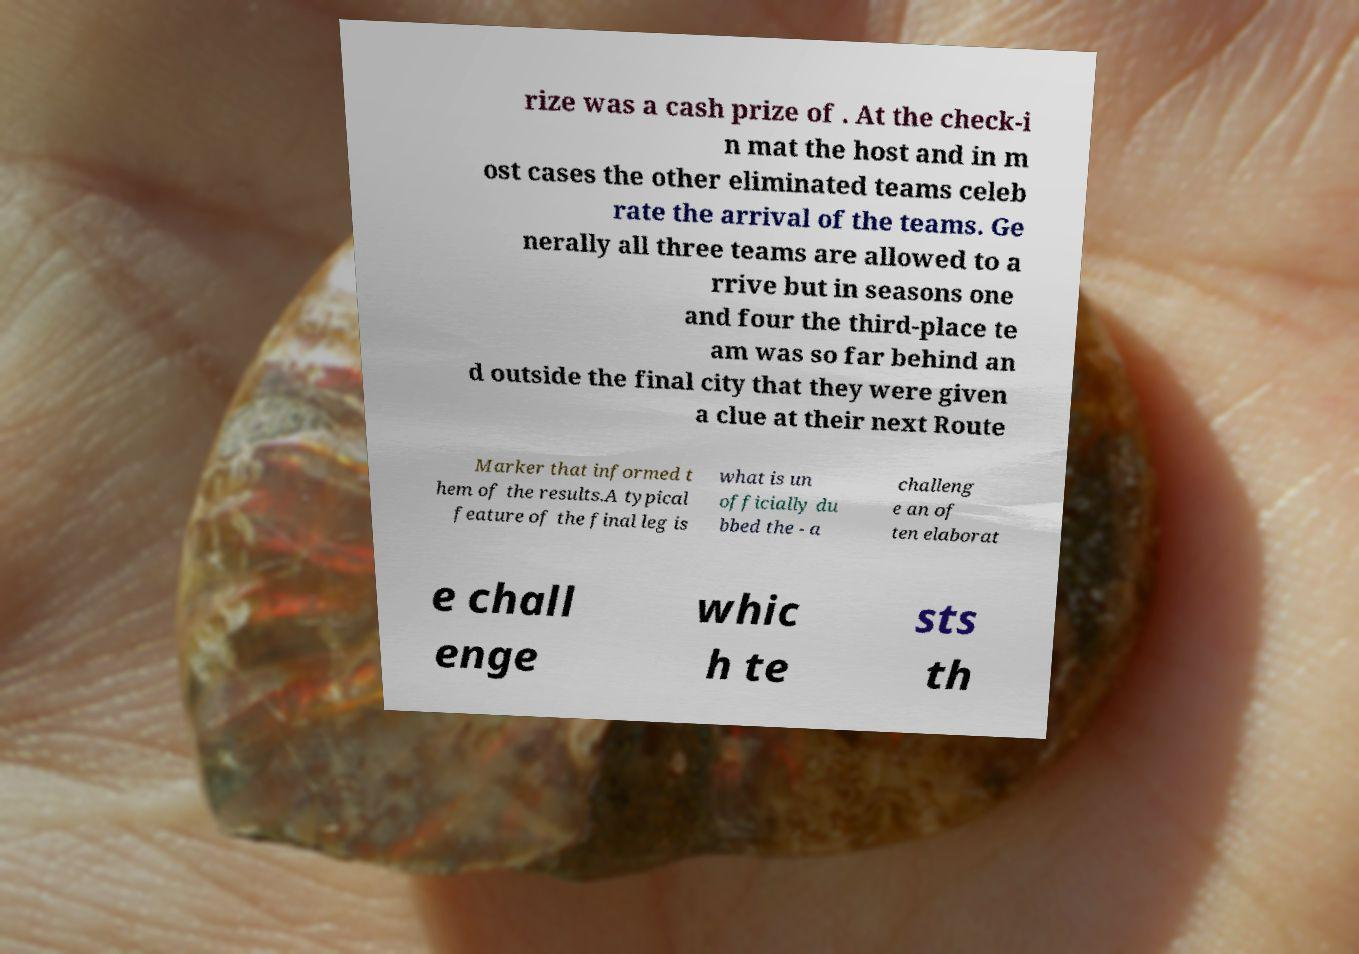Can you accurately transcribe the text from the provided image for me? rize was a cash prize of . At the check-i n mat the host and in m ost cases the other eliminated teams celeb rate the arrival of the teams. Ge nerally all three teams are allowed to a rrive but in seasons one and four the third-place te am was so far behind an d outside the final city that they were given a clue at their next Route Marker that informed t hem of the results.A typical feature of the final leg is what is un officially du bbed the - a challeng e an of ten elaborat e chall enge whic h te sts th 